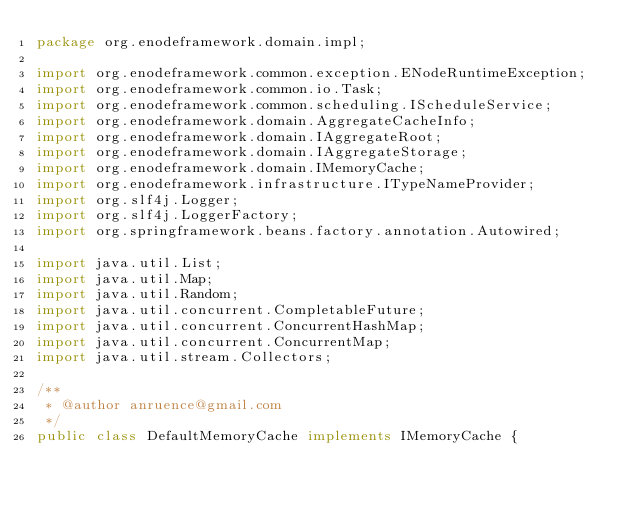Convert code to text. <code><loc_0><loc_0><loc_500><loc_500><_Java_>package org.enodeframework.domain.impl;

import org.enodeframework.common.exception.ENodeRuntimeException;
import org.enodeframework.common.io.Task;
import org.enodeframework.common.scheduling.IScheduleService;
import org.enodeframework.domain.AggregateCacheInfo;
import org.enodeframework.domain.IAggregateRoot;
import org.enodeframework.domain.IAggregateStorage;
import org.enodeframework.domain.IMemoryCache;
import org.enodeframework.infrastructure.ITypeNameProvider;
import org.slf4j.Logger;
import org.slf4j.LoggerFactory;
import org.springframework.beans.factory.annotation.Autowired;

import java.util.List;
import java.util.Map;
import java.util.Random;
import java.util.concurrent.CompletableFuture;
import java.util.concurrent.ConcurrentHashMap;
import java.util.concurrent.ConcurrentMap;
import java.util.stream.Collectors;

/**
 * @author anruence@gmail.com
 */
public class DefaultMemoryCache implements IMemoryCache {</code> 